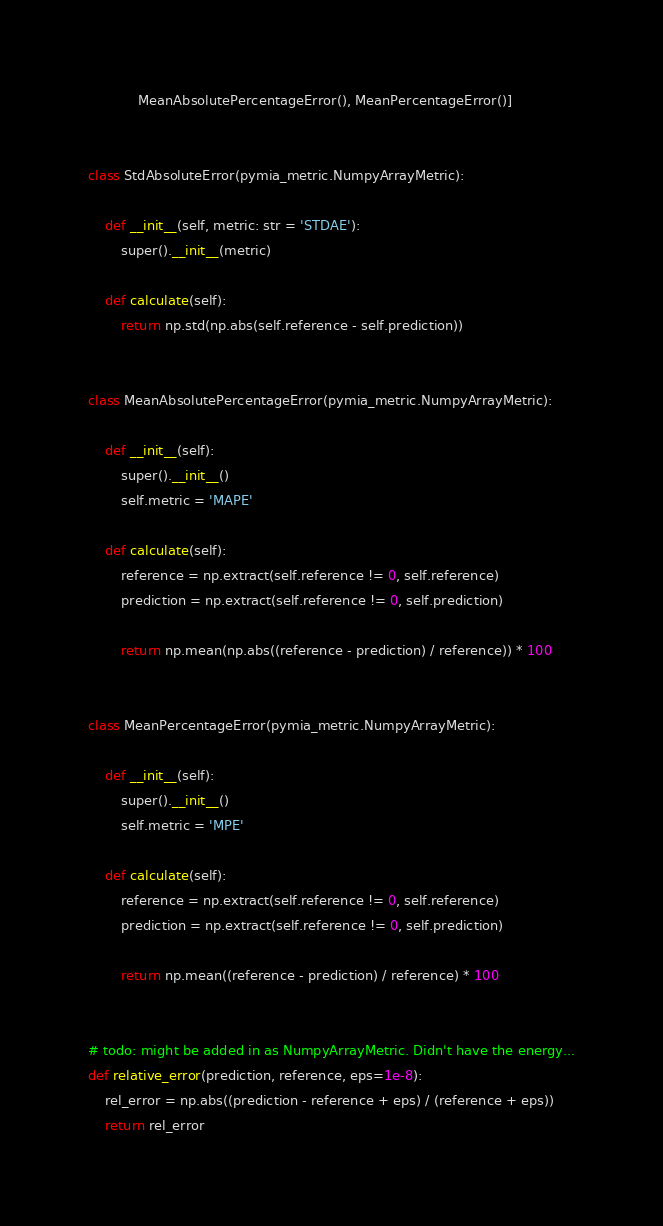<code> <loc_0><loc_0><loc_500><loc_500><_Python_>            MeanAbsolutePercentageError(), MeanPercentageError()]


class StdAbsoluteError(pymia_metric.NumpyArrayMetric):

    def __init__(self, metric: str = 'STDAE'):
        super().__init__(metric)

    def calculate(self):
        return np.std(np.abs(self.reference - self.prediction))


class MeanAbsolutePercentageError(pymia_metric.NumpyArrayMetric):

    def __init__(self):
        super().__init__()
        self.metric = 'MAPE'

    def calculate(self):
        reference = np.extract(self.reference != 0, self.reference)
        prediction = np.extract(self.reference != 0, self.prediction)

        return np.mean(np.abs((reference - prediction) / reference)) * 100


class MeanPercentageError(pymia_metric.NumpyArrayMetric):

    def __init__(self):
        super().__init__()
        self.metric = 'MPE'

    def calculate(self):
        reference = np.extract(self.reference != 0, self.reference)
        prediction = np.extract(self.reference != 0, self.prediction)

        return np.mean((reference - prediction) / reference) * 100


# todo: might be added in as NumpyArrayMetric. Didn't have the energy...
def relative_error(prediction, reference, eps=1e-8):
    rel_error = np.abs((prediction - reference + eps) / (reference + eps))
    return rel_error
</code> 